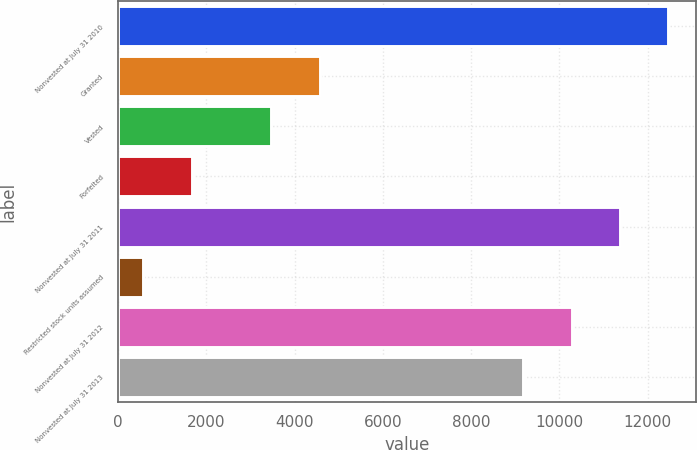<chart> <loc_0><loc_0><loc_500><loc_500><bar_chart><fcel>Nonvested at July 31 2010<fcel>Granted<fcel>Vested<fcel>Forfeited<fcel>Nonvested at July 31 2011<fcel>Restricted stock units assumed<fcel>Nonvested at July 31 2012<fcel>Nonvested at July 31 2013<nl><fcel>12470.8<fcel>4569.6<fcel>3474<fcel>1670.6<fcel>11375.2<fcel>575<fcel>10279.6<fcel>9184<nl></chart> 